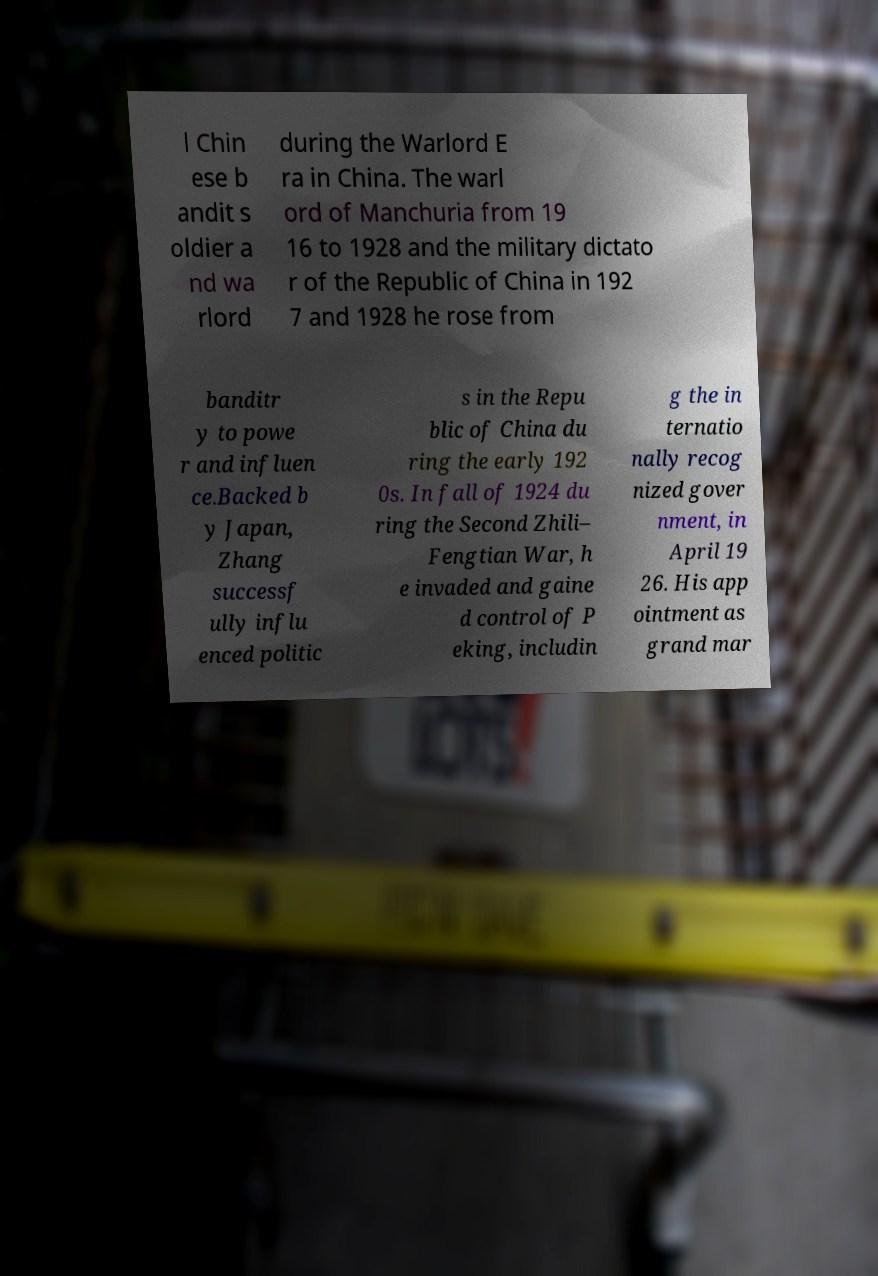Could you assist in decoding the text presented in this image and type it out clearly? l Chin ese b andit s oldier a nd wa rlord during the Warlord E ra in China. The warl ord of Manchuria from 19 16 to 1928 and the military dictato r of the Republic of China in 192 7 and 1928 he rose from banditr y to powe r and influen ce.Backed b y Japan, Zhang successf ully influ enced politic s in the Repu blic of China du ring the early 192 0s. In fall of 1924 du ring the Second Zhili– Fengtian War, h e invaded and gaine d control of P eking, includin g the in ternatio nally recog nized gover nment, in April 19 26. His app ointment as grand mar 